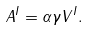Convert formula to latex. <formula><loc_0><loc_0><loc_500><loc_500>A ^ { I } = \alpha \gamma V ^ { I } .</formula> 